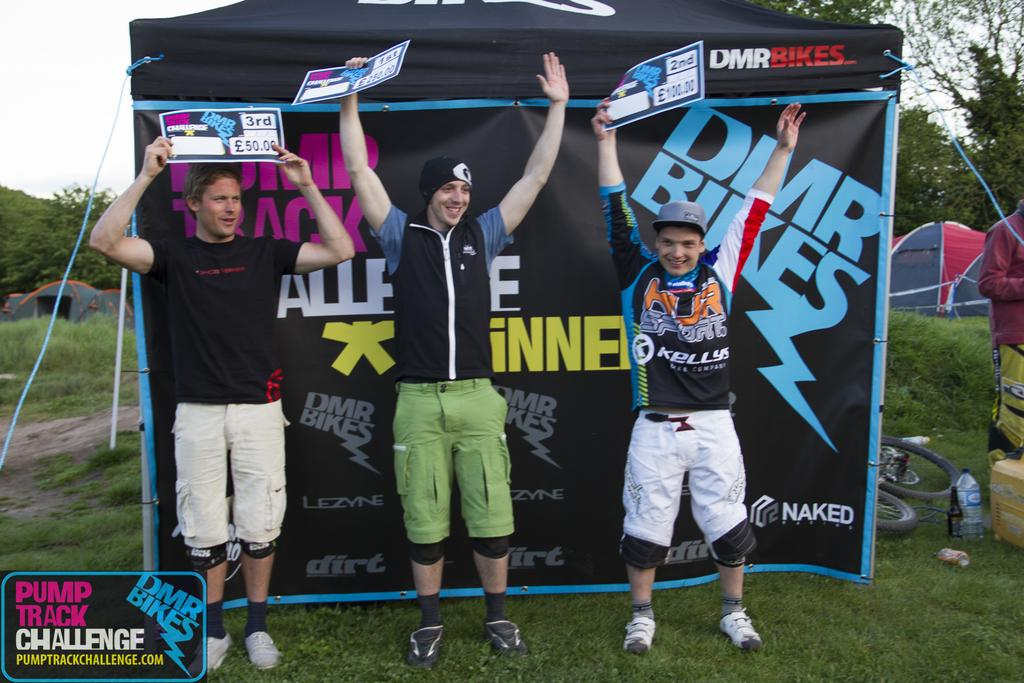<image>
Present a compact description of the photo's key features. Three young men stand before a DMR bikes and each one holds a DMR bikes sing in their hands. 